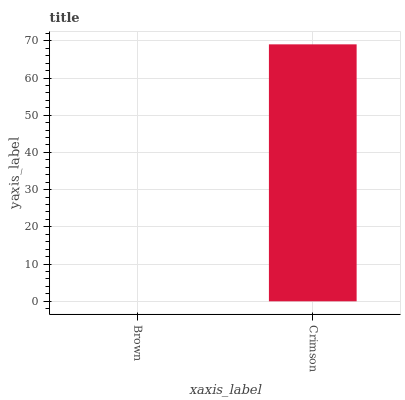Is Brown the minimum?
Answer yes or no. Yes. Is Crimson the maximum?
Answer yes or no. Yes. Is Crimson the minimum?
Answer yes or no. No. Is Crimson greater than Brown?
Answer yes or no. Yes. Is Brown less than Crimson?
Answer yes or no. Yes. Is Brown greater than Crimson?
Answer yes or no. No. Is Crimson less than Brown?
Answer yes or no. No. Is Crimson the high median?
Answer yes or no. Yes. Is Brown the low median?
Answer yes or no. Yes. Is Brown the high median?
Answer yes or no. No. Is Crimson the low median?
Answer yes or no. No. 